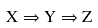<formula> <loc_0><loc_0><loc_500><loc_500>X \Rightarrow Y \Rightarrow Z</formula> 